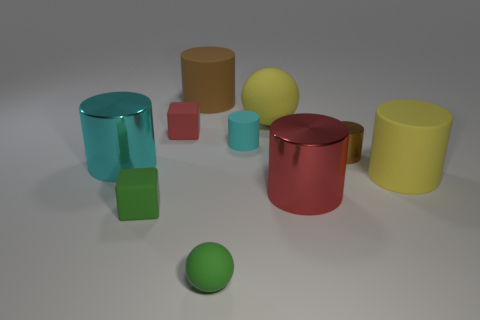What is the size of the matte thing that is the same color as the small matte ball?
Offer a terse response. Small. The other rubber cube that is the same size as the green block is what color?
Offer a very short reply. Red. The cyan rubber cylinder has what size?
Make the answer very short. Small. Is the material of the tiny thing that is behind the cyan matte object the same as the big cyan thing?
Make the answer very short. No. Does the big brown rubber thing have the same shape as the brown metal thing?
Ensure brevity in your answer.  Yes. There is a red object that is left of the big yellow thing that is left of the big yellow matte object in front of the cyan shiny thing; what shape is it?
Provide a short and direct response. Cube. There is a tiny green thing that is to the right of the tiny red matte thing; is it the same shape as the big yellow thing that is behind the tiny brown shiny cylinder?
Ensure brevity in your answer.  Yes. Is there a large yellow cylinder made of the same material as the large sphere?
Offer a very short reply. Yes. What color is the tiny rubber thing to the right of the tiny green sphere that is in front of the metal cylinder that is to the left of the red metallic cylinder?
Your answer should be very brief. Cyan. Is the block that is to the right of the green matte cube made of the same material as the cylinder to the left of the small green matte cube?
Your answer should be compact. No. 